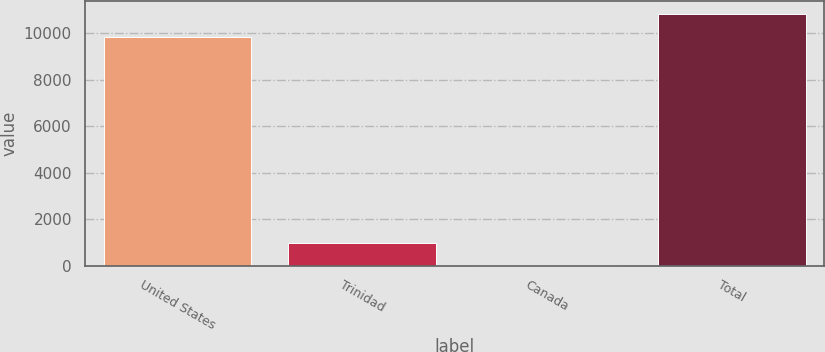Convert chart to OTSL. <chart><loc_0><loc_0><loc_500><loc_500><bar_chart><fcel>United States<fcel>Trinidad<fcel>Canada<fcel>Total<nl><fcel>9852<fcel>989.8<fcel>3<fcel>10838.8<nl></chart> 